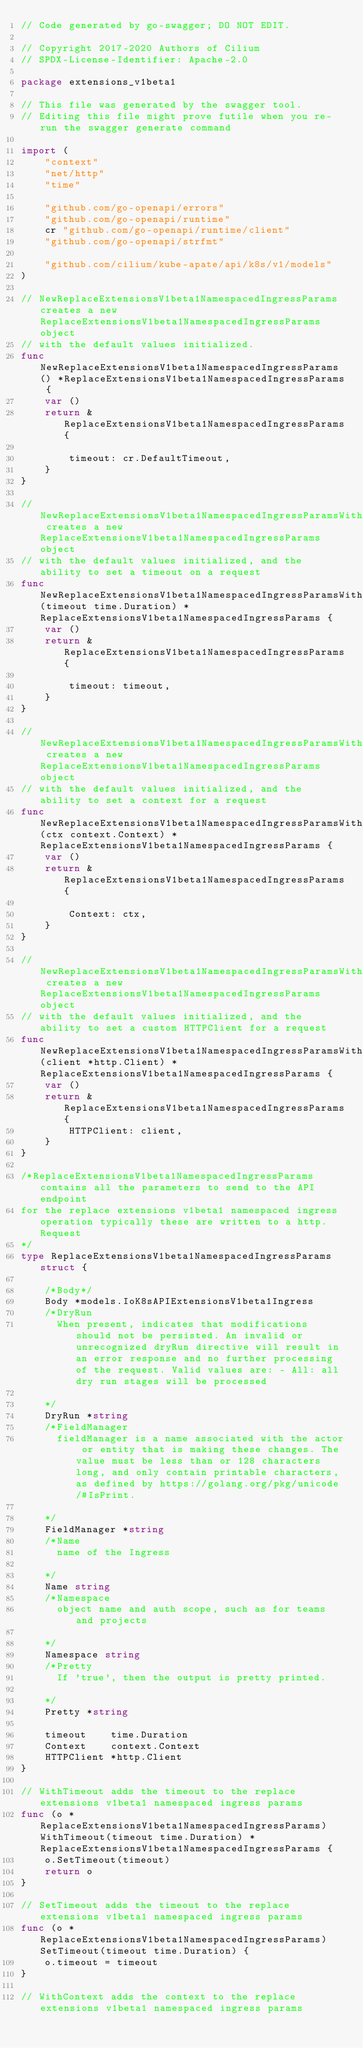<code> <loc_0><loc_0><loc_500><loc_500><_Go_>// Code generated by go-swagger; DO NOT EDIT.

// Copyright 2017-2020 Authors of Cilium
// SPDX-License-Identifier: Apache-2.0

package extensions_v1beta1

// This file was generated by the swagger tool.
// Editing this file might prove futile when you re-run the swagger generate command

import (
	"context"
	"net/http"
	"time"

	"github.com/go-openapi/errors"
	"github.com/go-openapi/runtime"
	cr "github.com/go-openapi/runtime/client"
	"github.com/go-openapi/strfmt"

	"github.com/cilium/kube-apate/api/k8s/v1/models"
)

// NewReplaceExtensionsV1beta1NamespacedIngressParams creates a new ReplaceExtensionsV1beta1NamespacedIngressParams object
// with the default values initialized.
func NewReplaceExtensionsV1beta1NamespacedIngressParams() *ReplaceExtensionsV1beta1NamespacedIngressParams {
	var ()
	return &ReplaceExtensionsV1beta1NamespacedIngressParams{

		timeout: cr.DefaultTimeout,
	}
}

// NewReplaceExtensionsV1beta1NamespacedIngressParamsWithTimeout creates a new ReplaceExtensionsV1beta1NamespacedIngressParams object
// with the default values initialized, and the ability to set a timeout on a request
func NewReplaceExtensionsV1beta1NamespacedIngressParamsWithTimeout(timeout time.Duration) *ReplaceExtensionsV1beta1NamespacedIngressParams {
	var ()
	return &ReplaceExtensionsV1beta1NamespacedIngressParams{

		timeout: timeout,
	}
}

// NewReplaceExtensionsV1beta1NamespacedIngressParamsWithContext creates a new ReplaceExtensionsV1beta1NamespacedIngressParams object
// with the default values initialized, and the ability to set a context for a request
func NewReplaceExtensionsV1beta1NamespacedIngressParamsWithContext(ctx context.Context) *ReplaceExtensionsV1beta1NamespacedIngressParams {
	var ()
	return &ReplaceExtensionsV1beta1NamespacedIngressParams{

		Context: ctx,
	}
}

// NewReplaceExtensionsV1beta1NamespacedIngressParamsWithHTTPClient creates a new ReplaceExtensionsV1beta1NamespacedIngressParams object
// with the default values initialized, and the ability to set a custom HTTPClient for a request
func NewReplaceExtensionsV1beta1NamespacedIngressParamsWithHTTPClient(client *http.Client) *ReplaceExtensionsV1beta1NamespacedIngressParams {
	var ()
	return &ReplaceExtensionsV1beta1NamespacedIngressParams{
		HTTPClient: client,
	}
}

/*ReplaceExtensionsV1beta1NamespacedIngressParams contains all the parameters to send to the API endpoint
for the replace extensions v1beta1 namespaced ingress operation typically these are written to a http.Request
*/
type ReplaceExtensionsV1beta1NamespacedIngressParams struct {

	/*Body*/
	Body *models.IoK8sAPIExtensionsV1beta1Ingress
	/*DryRun
	  When present, indicates that modifications should not be persisted. An invalid or unrecognized dryRun directive will result in an error response and no further processing of the request. Valid values are: - All: all dry run stages will be processed

	*/
	DryRun *string
	/*FieldManager
	  fieldManager is a name associated with the actor or entity that is making these changes. The value must be less than or 128 characters long, and only contain printable characters, as defined by https://golang.org/pkg/unicode/#IsPrint.

	*/
	FieldManager *string
	/*Name
	  name of the Ingress

	*/
	Name string
	/*Namespace
	  object name and auth scope, such as for teams and projects

	*/
	Namespace string
	/*Pretty
	  If 'true', then the output is pretty printed.

	*/
	Pretty *string

	timeout    time.Duration
	Context    context.Context
	HTTPClient *http.Client
}

// WithTimeout adds the timeout to the replace extensions v1beta1 namespaced ingress params
func (o *ReplaceExtensionsV1beta1NamespacedIngressParams) WithTimeout(timeout time.Duration) *ReplaceExtensionsV1beta1NamespacedIngressParams {
	o.SetTimeout(timeout)
	return o
}

// SetTimeout adds the timeout to the replace extensions v1beta1 namespaced ingress params
func (o *ReplaceExtensionsV1beta1NamespacedIngressParams) SetTimeout(timeout time.Duration) {
	o.timeout = timeout
}

// WithContext adds the context to the replace extensions v1beta1 namespaced ingress params</code> 